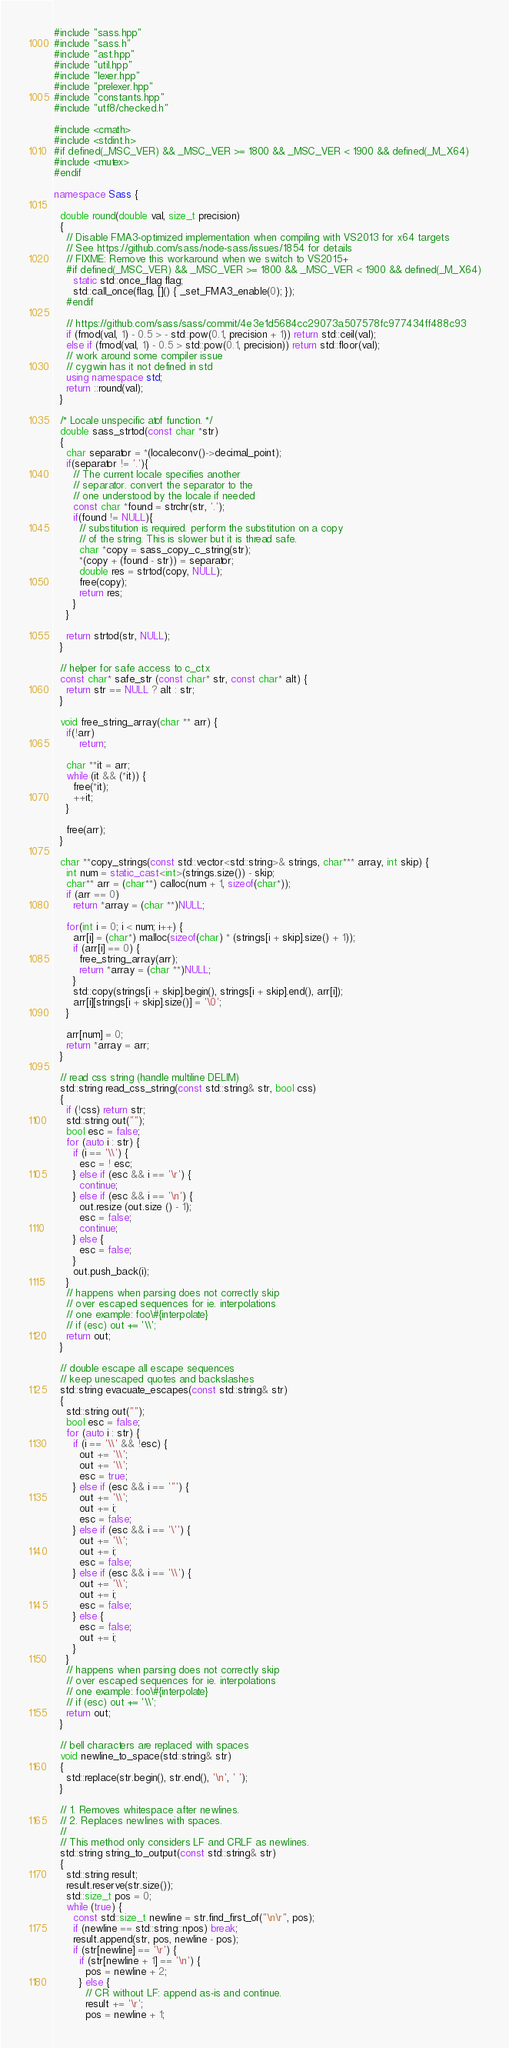<code> <loc_0><loc_0><loc_500><loc_500><_C++_>#include "sass.hpp"
#include "sass.h"
#include "ast.hpp"
#include "util.hpp"
#include "lexer.hpp"
#include "prelexer.hpp"
#include "constants.hpp"
#include "utf8/checked.h"

#include <cmath>
#include <stdint.h>
#if defined(_MSC_VER) && _MSC_VER >= 1800 && _MSC_VER < 1900 && defined(_M_X64)
#include <mutex>
#endif

namespace Sass {

  double round(double val, size_t precision)
  {
    // Disable FMA3-optimized implementation when compiling with VS2013 for x64 targets
    // See https://github.com/sass/node-sass/issues/1854 for details
    // FIXME: Remove this workaround when we switch to VS2015+
    #if defined(_MSC_VER) && _MSC_VER >= 1800 && _MSC_VER < 1900 && defined(_M_X64)
      static std::once_flag flag;
      std::call_once(flag, []() { _set_FMA3_enable(0); });
    #endif

    // https://github.com/sass/sass/commit/4e3e1d5684cc29073a507578fc977434ff488c93
    if (fmod(val, 1) - 0.5 > - std::pow(0.1, precision + 1)) return std::ceil(val);
    else if (fmod(val, 1) - 0.5 > std::pow(0.1, precision)) return std::floor(val);
    // work around some compiler issue
    // cygwin has it not defined in std
    using namespace std;
    return ::round(val);
  }

  /* Locale unspecific atof function. */
  double sass_strtod(const char *str)
  {
    char separator = *(localeconv()->decimal_point);
    if(separator != '.'){
      // The current locale specifies another
      // separator. convert the separator to the
      // one understood by the locale if needed
      const char *found = strchr(str, '.');
      if(found != NULL){
        // substitution is required. perform the substitution on a copy
        // of the string. This is slower but it is thread safe.
        char *copy = sass_copy_c_string(str);
        *(copy + (found - str)) = separator;
        double res = strtod(copy, NULL);
        free(copy);
        return res;
      }
    }

    return strtod(str, NULL);
  }

  // helper for safe access to c_ctx
  const char* safe_str (const char* str, const char* alt) {
    return str == NULL ? alt : str;
  }

  void free_string_array(char ** arr) {
    if(!arr)
        return;

    char **it = arr;
    while (it && (*it)) {
      free(*it);
      ++it;
    }

    free(arr);
  }

  char **copy_strings(const std::vector<std::string>& strings, char*** array, int skip) {
    int num = static_cast<int>(strings.size()) - skip;
    char** arr = (char**) calloc(num + 1, sizeof(char*));
    if (arr == 0)
      return *array = (char **)NULL;

    for(int i = 0; i < num; i++) {
      arr[i] = (char*) malloc(sizeof(char) * (strings[i + skip].size() + 1));
      if (arr[i] == 0) {
        free_string_array(arr);
        return *array = (char **)NULL;
      }
      std::copy(strings[i + skip].begin(), strings[i + skip].end(), arr[i]);
      arr[i][strings[i + skip].size()] = '\0';
    }

    arr[num] = 0;
    return *array = arr;
  }

  // read css string (handle multiline DELIM)
  std::string read_css_string(const std::string& str, bool css)
  {
    if (!css) return str;
    std::string out("");
    bool esc = false;
    for (auto i : str) {
      if (i == '\\') {
        esc = ! esc;
      } else if (esc && i == '\r') {
        continue;
      } else if (esc && i == '\n') {
        out.resize (out.size () - 1);
        esc = false;
        continue;
      } else {
        esc = false;
      }
      out.push_back(i);
    }
    // happens when parsing does not correctly skip
    // over escaped sequences for ie. interpolations
    // one example: foo\#{interpolate}
    // if (esc) out += '\\';
    return out;
  }

  // double escape all escape sequences
  // keep unescaped quotes and backslashes
  std::string evacuate_escapes(const std::string& str)
  {
    std::string out("");
    bool esc = false;
    for (auto i : str) {
      if (i == '\\' && !esc) {
        out += '\\';
        out += '\\';
        esc = true;
      } else if (esc && i == '"') {
        out += '\\';
        out += i;
        esc = false;
      } else if (esc && i == '\'') {
        out += '\\';
        out += i;
        esc = false;
      } else if (esc && i == '\\') {
        out += '\\';
        out += i;
        esc = false;
      } else {
        esc = false;
        out += i;
      }
    }
    // happens when parsing does not correctly skip
    // over escaped sequences for ie. interpolations
    // one example: foo\#{interpolate}
    // if (esc) out += '\\';
    return out;
  }

  // bell characters are replaced with spaces
  void newline_to_space(std::string& str)
  {
    std::replace(str.begin(), str.end(), '\n', ' ');
  }

  // 1. Removes whitespace after newlines.
  // 2. Replaces newlines with spaces.
  //
  // This method only considers LF and CRLF as newlines.
  std::string string_to_output(const std::string& str)
  {
    std::string result;
    result.reserve(str.size());
    std::size_t pos = 0;
    while (true) {
      const std::size_t newline = str.find_first_of("\n\r", pos);
      if (newline == std::string::npos) break;
      result.append(str, pos, newline - pos);
      if (str[newline] == '\r') {
        if (str[newline + 1] == '\n') {
          pos = newline + 2;
        } else {
          // CR without LF: append as-is and continue.
          result += '\r';
          pos = newline + 1;</code> 